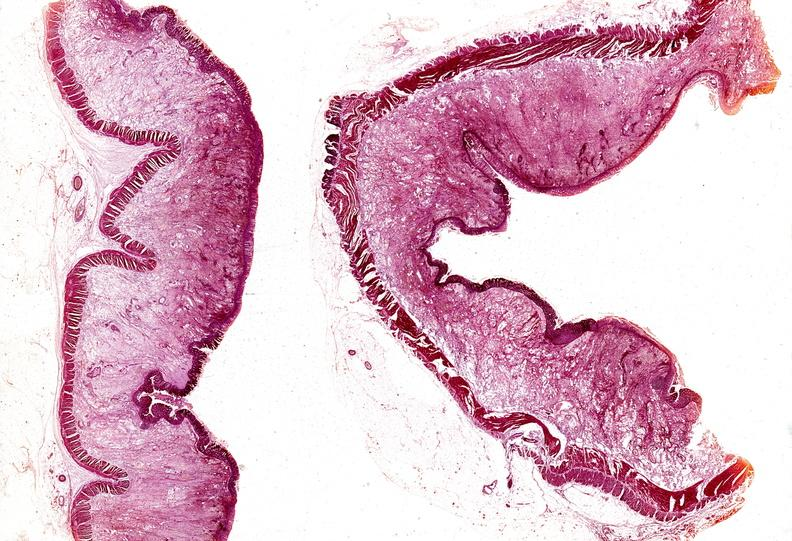what does this image show?
Answer the question using a single word or phrase. Colon 